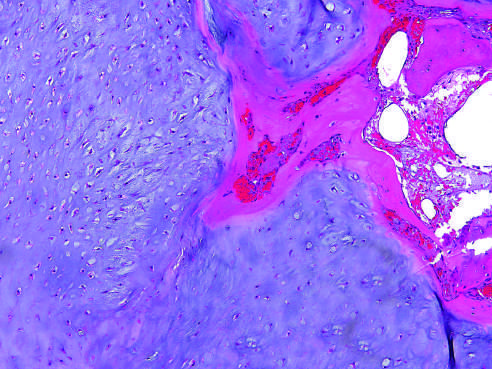s the adrenal cortex encased by a thin layer of reactive bone?
Answer the question using a single word or phrase. No 